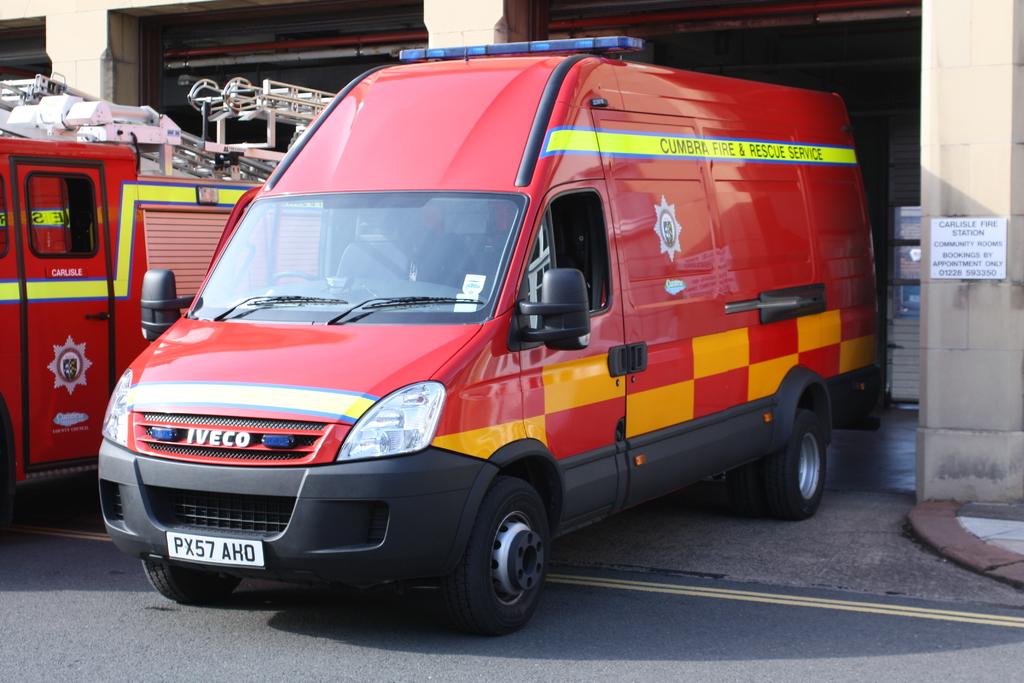What's the plate number?
Offer a very short reply. Px57aho. What is the brand of the van?
Give a very brief answer. Iveco. 